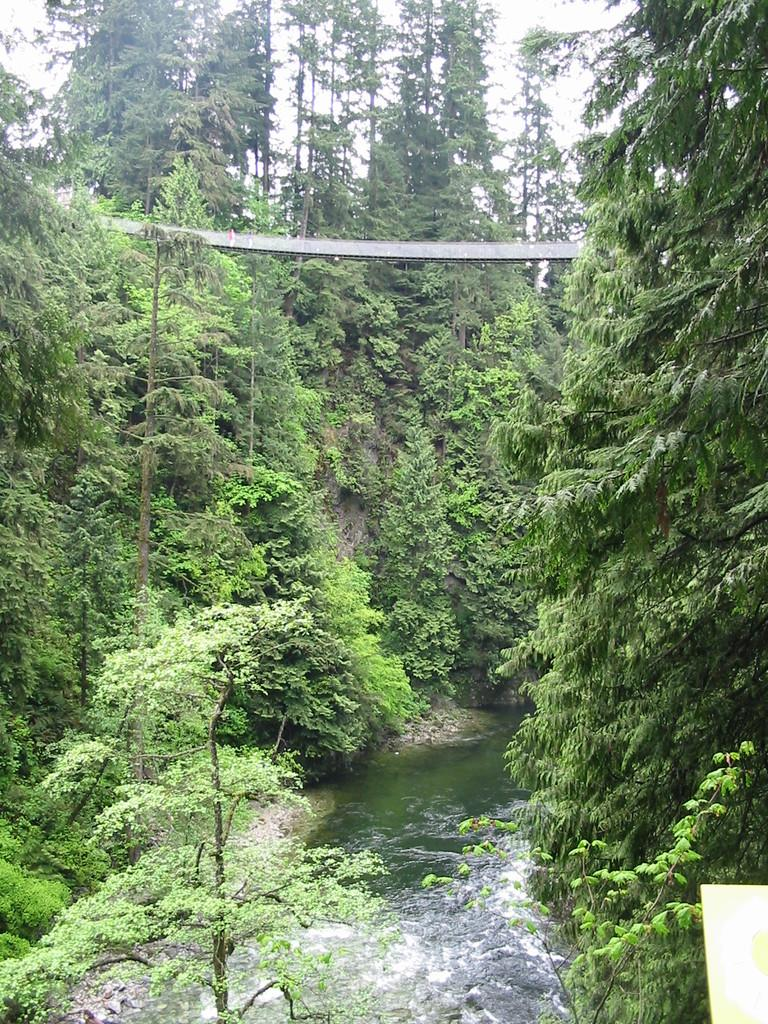What is the main feature of the image? There is a river in the picture. What can be seen around the river? There are trees around the river. What type of key is used to unlock the beef in the image? There is no key or beef present in the image; it features a river and trees. How many cakes are visible in the image? There are no cakes present in the image; it features a river and trees. 